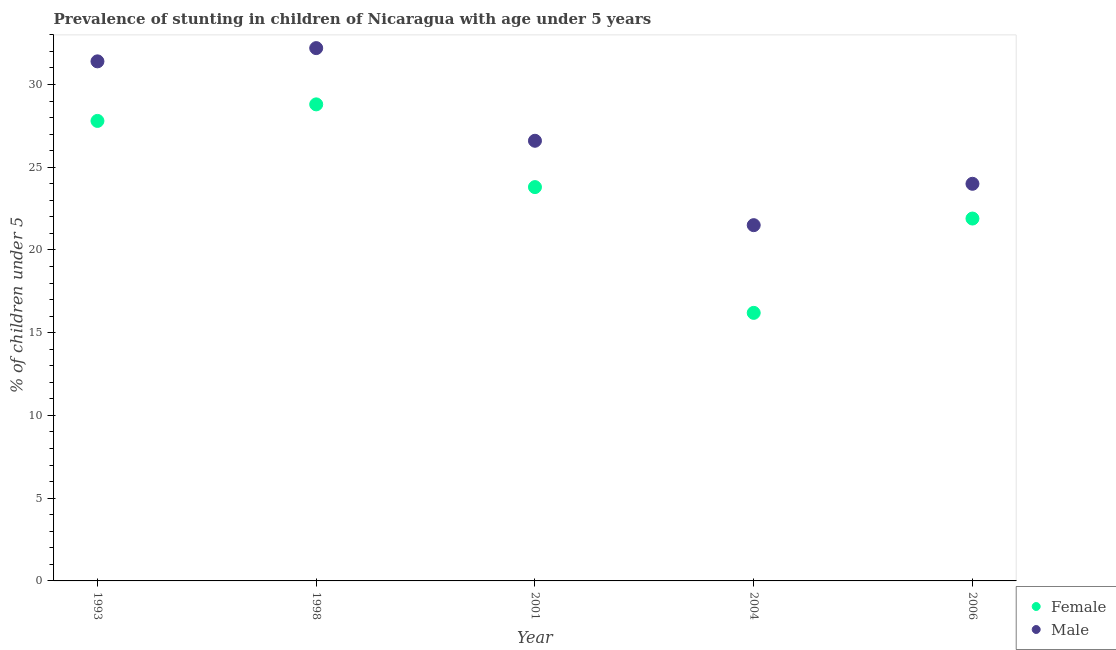What is the percentage of stunted male children in 1993?
Offer a terse response. 31.4. Across all years, what is the maximum percentage of stunted male children?
Ensure brevity in your answer.  32.2. Across all years, what is the minimum percentage of stunted female children?
Give a very brief answer. 16.2. What is the total percentage of stunted male children in the graph?
Keep it short and to the point. 135.7. What is the difference between the percentage of stunted female children in 1993 and that in 2004?
Your answer should be compact. 11.6. What is the difference between the percentage of stunted male children in 2006 and the percentage of stunted female children in 1998?
Offer a very short reply. -4.8. What is the average percentage of stunted male children per year?
Offer a terse response. 27.14. In the year 2004, what is the difference between the percentage of stunted male children and percentage of stunted female children?
Keep it short and to the point. 5.3. In how many years, is the percentage of stunted female children greater than 9 %?
Your answer should be very brief. 5. What is the ratio of the percentage of stunted female children in 1998 to that in 2006?
Offer a very short reply. 1.32. Is the percentage of stunted male children in 1998 less than that in 2004?
Provide a succinct answer. No. What is the difference between the highest and the second highest percentage of stunted male children?
Your response must be concise. 0.8. What is the difference between the highest and the lowest percentage of stunted male children?
Your answer should be very brief. 10.7. In how many years, is the percentage of stunted female children greater than the average percentage of stunted female children taken over all years?
Your answer should be very brief. 3. Is the sum of the percentage of stunted male children in 1993 and 2006 greater than the maximum percentage of stunted female children across all years?
Ensure brevity in your answer.  Yes. Does the percentage of stunted male children monotonically increase over the years?
Ensure brevity in your answer.  No. How many years are there in the graph?
Make the answer very short. 5. Does the graph contain any zero values?
Give a very brief answer. No. Does the graph contain grids?
Offer a terse response. No. What is the title of the graph?
Offer a very short reply. Prevalence of stunting in children of Nicaragua with age under 5 years. What is the label or title of the Y-axis?
Your answer should be very brief.  % of children under 5. What is the  % of children under 5 of Female in 1993?
Provide a short and direct response. 27.8. What is the  % of children under 5 in Male in 1993?
Offer a very short reply. 31.4. What is the  % of children under 5 in Female in 1998?
Provide a short and direct response. 28.8. What is the  % of children under 5 of Male in 1998?
Offer a very short reply. 32.2. What is the  % of children under 5 of Female in 2001?
Offer a terse response. 23.8. What is the  % of children under 5 in Male in 2001?
Provide a short and direct response. 26.6. What is the  % of children under 5 in Female in 2004?
Offer a very short reply. 16.2. What is the  % of children under 5 of Female in 2006?
Ensure brevity in your answer.  21.9. Across all years, what is the maximum  % of children under 5 in Female?
Ensure brevity in your answer.  28.8. Across all years, what is the maximum  % of children under 5 in Male?
Provide a succinct answer. 32.2. Across all years, what is the minimum  % of children under 5 in Female?
Offer a very short reply. 16.2. Across all years, what is the minimum  % of children under 5 in Male?
Provide a short and direct response. 21.5. What is the total  % of children under 5 in Female in the graph?
Provide a succinct answer. 118.5. What is the total  % of children under 5 in Male in the graph?
Your response must be concise. 135.7. What is the difference between the  % of children under 5 in Female in 1993 and that in 2001?
Provide a succinct answer. 4. What is the difference between the  % of children under 5 of Female in 1993 and that in 2006?
Your response must be concise. 5.9. What is the difference between the  % of children under 5 of Male in 1993 and that in 2006?
Offer a terse response. 7.4. What is the difference between the  % of children under 5 of Female in 1998 and that in 2001?
Your answer should be very brief. 5. What is the difference between the  % of children under 5 of Male in 1998 and that in 2004?
Offer a terse response. 10.7. What is the difference between the  % of children under 5 of Male in 1998 and that in 2006?
Offer a very short reply. 8.2. What is the difference between the  % of children under 5 of Female in 2001 and that in 2004?
Give a very brief answer. 7.6. What is the difference between the  % of children under 5 of Male in 2001 and that in 2004?
Keep it short and to the point. 5.1. What is the difference between the  % of children under 5 of Female in 2001 and that in 2006?
Offer a very short reply. 1.9. What is the difference between the  % of children under 5 in Female in 1993 and the  % of children under 5 in Male in 2004?
Give a very brief answer. 6.3. What is the difference between the  % of children under 5 in Female in 1993 and the  % of children under 5 in Male in 2006?
Your response must be concise. 3.8. What is the difference between the  % of children under 5 of Female in 1998 and the  % of children under 5 of Male in 2001?
Offer a terse response. 2.2. What is the difference between the  % of children under 5 in Female in 2001 and the  % of children under 5 in Male in 2006?
Provide a succinct answer. -0.2. What is the difference between the  % of children under 5 of Female in 2004 and the  % of children under 5 of Male in 2006?
Give a very brief answer. -7.8. What is the average  % of children under 5 in Female per year?
Make the answer very short. 23.7. What is the average  % of children under 5 of Male per year?
Your answer should be very brief. 27.14. In the year 1993, what is the difference between the  % of children under 5 of Female and  % of children under 5 of Male?
Ensure brevity in your answer.  -3.6. In the year 1998, what is the difference between the  % of children under 5 of Female and  % of children under 5 of Male?
Provide a succinct answer. -3.4. What is the ratio of the  % of children under 5 in Female in 1993 to that in 1998?
Your answer should be very brief. 0.97. What is the ratio of the  % of children under 5 of Male in 1993 to that in 1998?
Ensure brevity in your answer.  0.98. What is the ratio of the  % of children under 5 in Female in 1993 to that in 2001?
Your answer should be compact. 1.17. What is the ratio of the  % of children under 5 in Male in 1993 to that in 2001?
Provide a succinct answer. 1.18. What is the ratio of the  % of children under 5 of Female in 1993 to that in 2004?
Provide a short and direct response. 1.72. What is the ratio of the  % of children under 5 in Male in 1993 to that in 2004?
Your response must be concise. 1.46. What is the ratio of the  % of children under 5 of Female in 1993 to that in 2006?
Offer a very short reply. 1.27. What is the ratio of the  % of children under 5 of Male in 1993 to that in 2006?
Provide a short and direct response. 1.31. What is the ratio of the  % of children under 5 in Female in 1998 to that in 2001?
Offer a very short reply. 1.21. What is the ratio of the  % of children under 5 in Male in 1998 to that in 2001?
Provide a succinct answer. 1.21. What is the ratio of the  % of children under 5 in Female in 1998 to that in 2004?
Your answer should be very brief. 1.78. What is the ratio of the  % of children under 5 of Male in 1998 to that in 2004?
Your answer should be very brief. 1.5. What is the ratio of the  % of children under 5 of Female in 1998 to that in 2006?
Provide a short and direct response. 1.32. What is the ratio of the  % of children under 5 in Male in 1998 to that in 2006?
Provide a succinct answer. 1.34. What is the ratio of the  % of children under 5 of Female in 2001 to that in 2004?
Your answer should be very brief. 1.47. What is the ratio of the  % of children under 5 in Male in 2001 to that in 2004?
Your answer should be compact. 1.24. What is the ratio of the  % of children under 5 in Female in 2001 to that in 2006?
Provide a short and direct response. 1.09. What is the ratio of the  % of children under 5 in Male in 2001 to that in 2006?
Your response must be concise. 1.11. What is the ratio of the  % of children under 5 in Female in 2004 to that in 2006?
Provide a short and direct response. 0.74. What is the ratio of the  % of children under 5 in Male in 2004 to that in 2006?
Give a very brief answer. 0.9. What is the difference between the highest and the second highest  % of children under 5 of Female?
Your answer should be compact. 1. What is the difference between the highest and the lowest  % of children under 5 of Female?
Give a very brief answer. 12.6. What is the difference between the highest and the lowest  % of children under 5 in Male?
Provide a succinct answer. 10.7. 